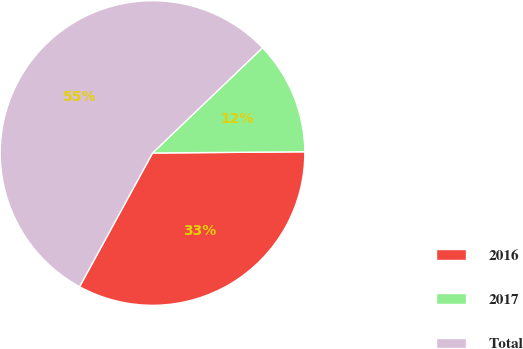Convert chart to OTSL. <chart><loc_0><loc_0><loc_500><loc_500><pie_chart><fcel>2016<fcel>2017<fcel>Total<nl><fcel>33.09%<fcel>12.02%<fcel>54.9%<nl></chart> 